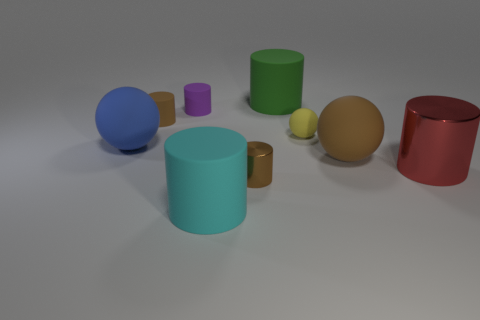Is there a tiny green shiny thing of the same shape as the purple matte object?
Your response must be concise. No. Are the big red cylinder and the brown cylinder behind the red shiny thing made of the same material?
Offer a very short reply. No. There is a large matte cylinder that is behind the shiny cylinder on the right side of the brown cylinder in front of the large blue thing; what color is it?
Give a very brief answer. Green. There is a red object that is the same size as the brown sphere; what is it made of?
Offer a very short reply. Metal. How many small things have the same material as the large red cylinder?
Keep it short and to the point. 1. Does the brown object in front of the red shiny cylinder have the same size as the matte object that is in front of the large brown object?
Make the answer very short. No. There is a large matte thing that is left of the small brown rubber cylinder; what color is it?
Keep it short and to the point. Blue. There is a ball that is the same color as the tiny metallic object; what is its material?
Offer a terse response. Rubber. What number of large matte balls are the same color as the small rubber sphere?
Your answer should be compact. 0. There is a brown matte sphere; does it have the same size as the brown cylinder behind the blue rubber ball?
Make the answer very short. No. 